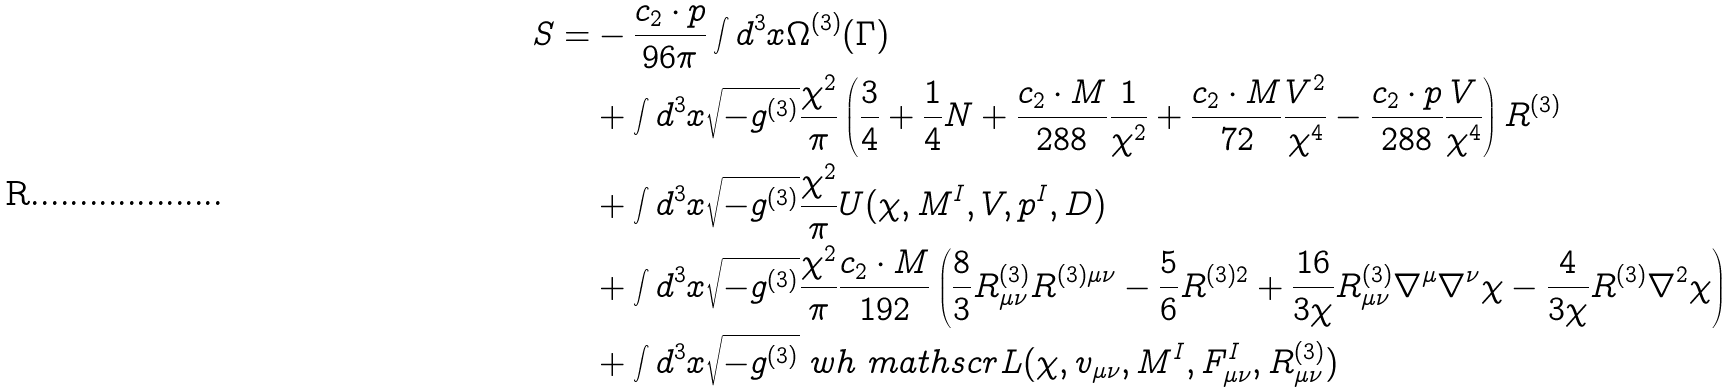<formula> <loc_0><loc_0><loc_500><loc_500>S = & - \frac { c _ { 2 } \cdot p } { 9 6 \pi } \int d ^ { 3 } x \Omega ^ { ( 3 ) } ( { \Gamma } ) \\ & + \int d ^ { 3 } x \sqrt { - g ^ { ( 3 ) } } \frac { \chi ^ { 2 } } { \pi } \left ( \frac { 3 } { 4 } + \frac { 1 } { 4 } N + \frac { c _ { 2 } \cdot M } { 2 8 8 } \frac { 1 } { \chi ^ { 2 } } + \frac { c _ { 2 } \cdot M } { 7 2 } \frac { V ^ { 2 } } { \chi ^ { 4 } } - \frac { c _ { 2 } \cdot p } { 2 8 8 } \frac { V } { \chi ^ { 4 } } \right ) R ^ { ( 3 ) } \\ & + \int d ^ { 3 } x \sqrt { - g ^ { ( 3 ) } } \frac { \chi ^ { 2 } } { \pi } U ( \chi , M ^ { I } , V , p ^ { I } , D ) \\ & + \int d ^ { 3 } x \sqrt { - g ^ { ( 3 ) } } \frac { \chi ^ { 2 } } { \pi } \frac { c _ { 2 } \cdot M } { 1 9 2 } \left ( \frac { 8 } { 3 } R ^ { ( 3 ) } _ { \mu \nu } R ^ { ( 3 ) \mu \nu } - \frac { 5 } { 6 } R ^ { ( 3 ) 2 } + \frac { 1 6 } { 3 \chi } R ^ { ( 3 ) } _ { \mu \nu } \nabla ^ { \mu } \nabla ^ { \nu } \chi - \frac { 4 } { 3 \chi } R ^ { ( 3 ) } \nabla ^ { 2 } \chi \right ) \\ & + \int d ^ { 3 } x \sqrt { - g ^ { ( 3 ) } } \ w h { \ m a t h s c r { L } } ( \chi , v _ { \mu \nu } , M ^ { I } , F ^ { I } _ { \mu \nu } , R ^ { ( 3 ) } _ { \mu \nu } )</formula> 